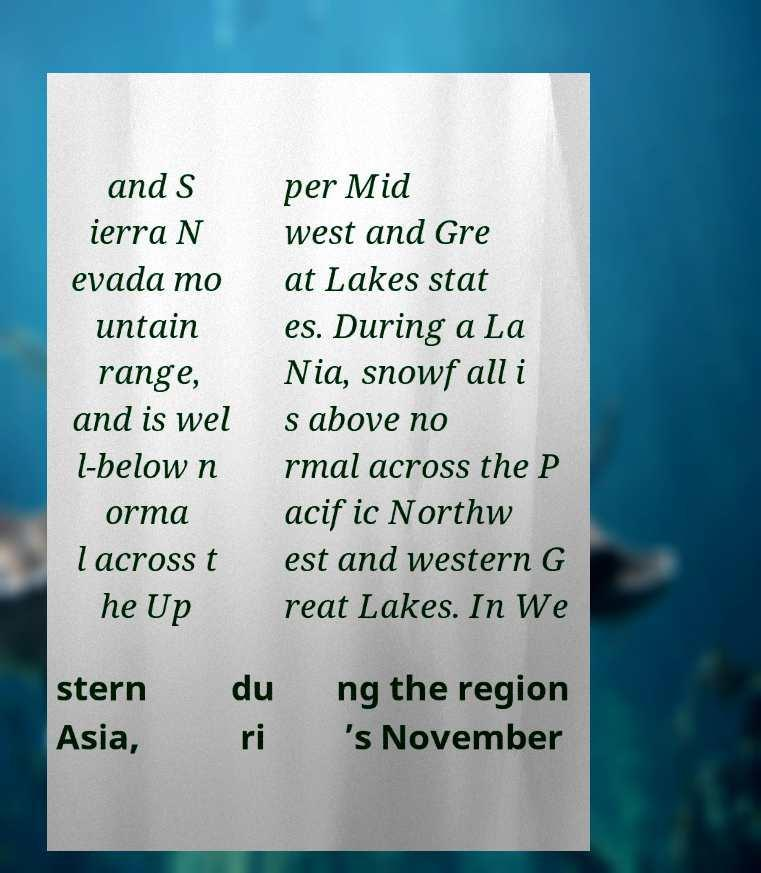For documentation purposes, I need the text within this image transcribed. Could you provide that? and S ierra N evada mo untain range, and is wel l-below n orma l across t he Up per Mid west and Gre at Lakes stat es. During a La Nia, snowfall i s above no rmal across the P acific Northw est and western G reat Lakes. In We stern Asia, du ri ng the region ’s November 